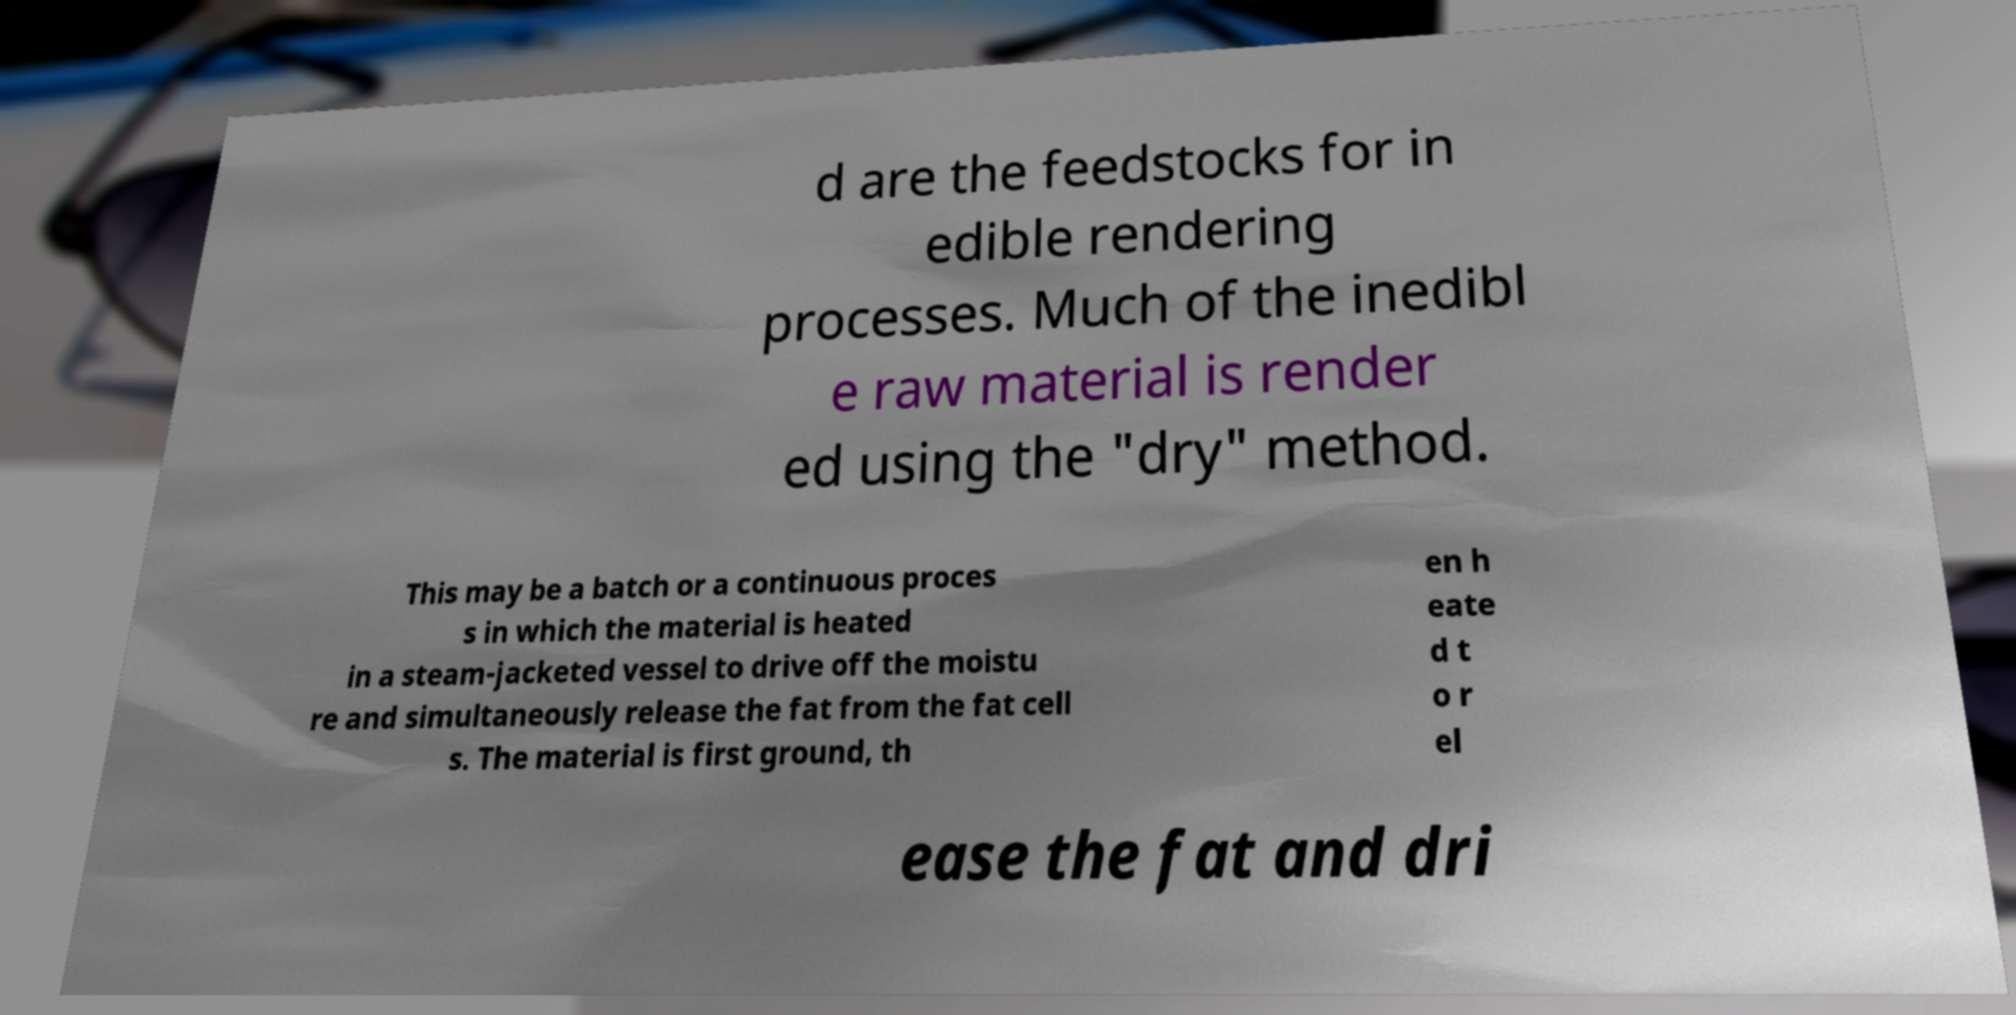There's text embedded in this image that I need extracted. Can you transcribe it verbatim? d are the feedstocks for in edible rendering processes. Much of the inedibl e raw material is render ed using the "dry" method. This may be a batch or a continuous proces s in which the material is heated in a steam-jacketed vessel to drive off the moistu re and simultaneously release the fat from the fat cell s. The material is first ground, th en h eate d t o r el ease the fat and dri 